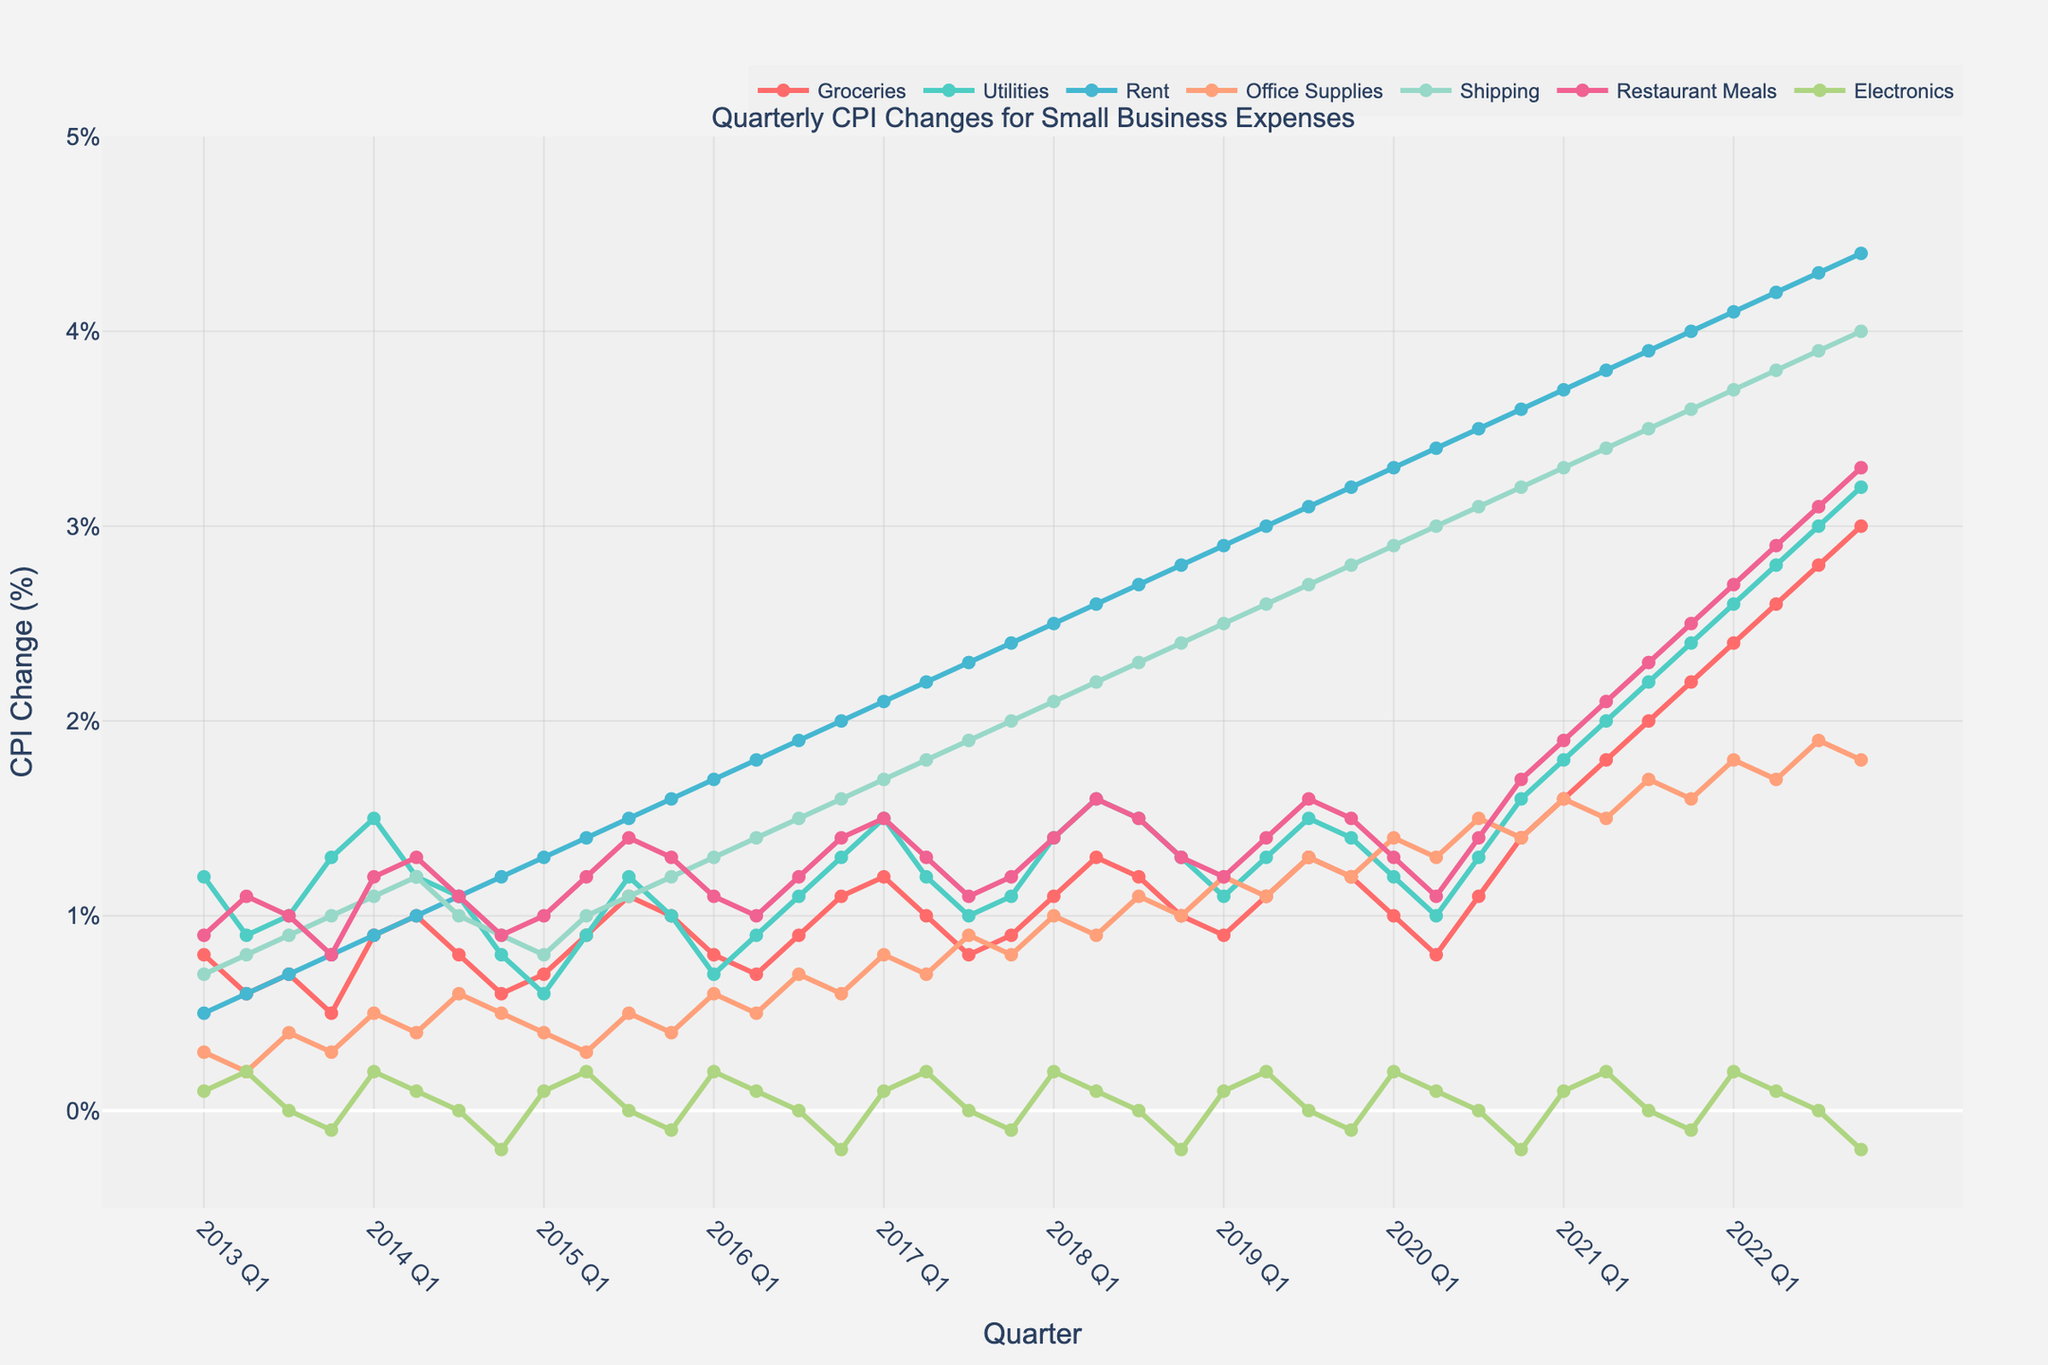What's the trend of CPI changes for Rent from 2013 to 2022? Over the years, the CPI for Rent has shown a steady upward trend from 0.5% in 2013 Q1 to 4.4% in 2022 Q4. This continuous increase can be observed clearly on the line chart, indicating a consistent rise in rental costs over the decade.
Answer: Consistent upward trend Which category had the highest CPI change in 2022 Q4? In 2022 Q4, the category with the highest CPI change is 'Groceries' with a value of 3.0%, as indicated by the peak in the grocerie's line compared to the other categories in the final quarter.
Answer: Groceries Comparing the first and the last quarter data, how much did the CPI for Utilities increase from 2013 Q1 to 2022 Q4? The CPI for Utilities in 2013 Q1 was 1.2%. By 2022 Q4, it increased to 3.2%. The difference between these values is 3.2% - 1.2% = 2.0%.
Answer: 2.0% Aggregating quarterly data throughout the decade, which category shows the least variability in CPI changes? 'Electronics' shows the least variability as its line is relatively flat compared to other categories. Over the years, it ranges between -0.2% and 0.2%, indicating minimal fluctuations.
Answer: Electronics Which category's CPI exhibited the most significant drop within a quarter over the decade, and when did it occur? 'Electronics' exhibited the most significant drop, with a decrease from 0.2% to -0.2% between 2014 Q3 and 2014 Q4, as is evident from the sharp dip in the Electronics line during this period.
Answer: Electronics, 2014 Q3 to 2014 Q4 At which quarter did Office Supplies have its highest CPI change, and what was the value? Office Supplies had its highest CPI change in 2020 Q3 with a value of 1.5%, as seen from the peak in the Office Supplies line on the chart at that quarter.
Answer: 2020 Q3, 1.5% What's the total cumulative change of the CPI for Shipping from 2013 Q1 to 2022 Q4? To determine the cumulative change, we need to sum up the quarterly changes from 2013 Q1 to 2022 Q4. By adding up all the values in the Shipping category: 0.7 + 0.8 + 0.9 + ... + 4.0, we get the total cumulative change for the decade.
Answer: Cumulative sum of quarterly changes How does the CPI for Restaurant Meals in 2022 compare to its average value in 2013? The average CPI for Restaurant Meals in 2013 can be calculated by taking the mean of its quarterly values: (0.9 + 1.1 + 1.0 + 0.8)/4 = 0.95%. The CPI in 2022 Q4 is 3.3%. The comparison shows a significant increase from 0.95% to 3.3%.
Answer: Increased significantly Which quarter saw the highest CPI change for Groceries, and what was the value? The highest CPI change for Groceries occurred in 2022 Q4 with a value of 3.0%, as indicated by the peak in the Groceries line on the chart.
Answer: 2022 Q4, 3.0% 